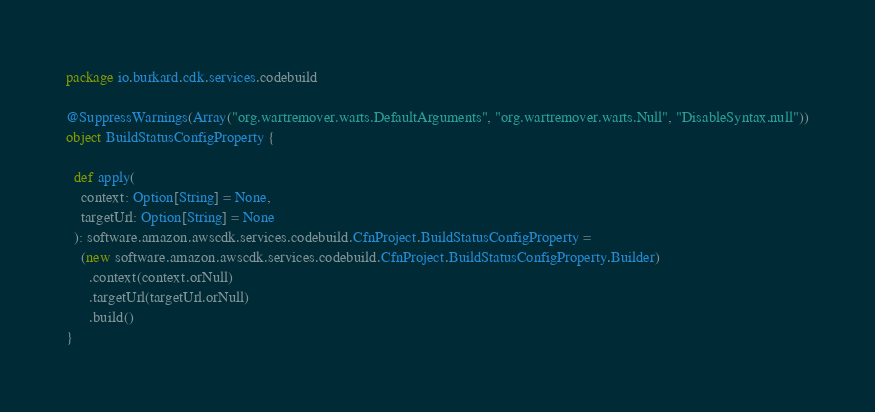<code> <loc_0><loc_0><loc_500><loc_500><_Scala_>package io.burkard.cdk.services.codebuild

@SuppressWarnings(Array("org.wartremover.warts.DefaultArguments", "org.wartremover.warts.Null", "DisableSyntax.null"))
object BuildStatusConfigProperty {

  def apply(
    context: Option[String] = None,
    targetUrl: Option[String] = None
  ): software.amazon.awscdk.services.codebuild.CfnProject.BuildStatusConfigProperty =
    (new software.amazon.awscdk.services.codebuild.CfnProject.BuildStatusConfigProperty.Builder)
      .context(context.orNull)
      .targetUrl(targetUrl.orNull)
      .build()
}
</code> 